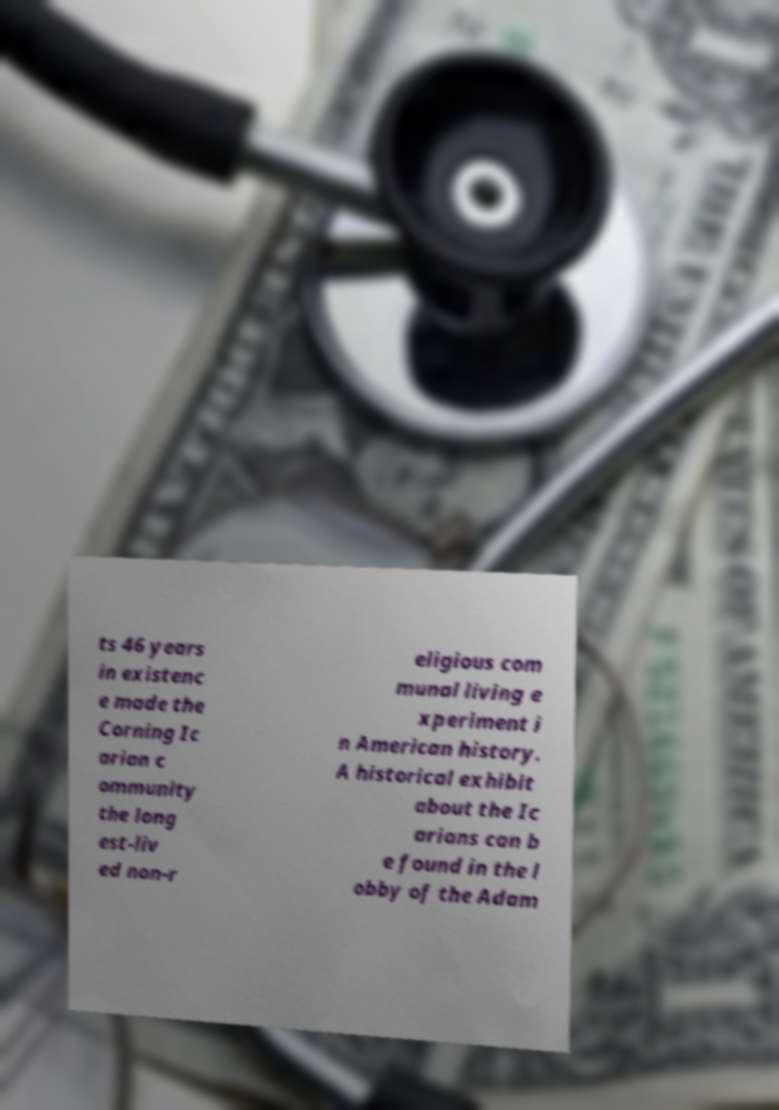Can you accurately transcribe the text from the provided image for me? ts 46 years in existenc e made the Corning Ic arian c ommunity the long est-liv ed non-r eligious com munal living e xperiment i n American history. A historical exhibit about the Ic arians can b e found in the l obby of the Adam 